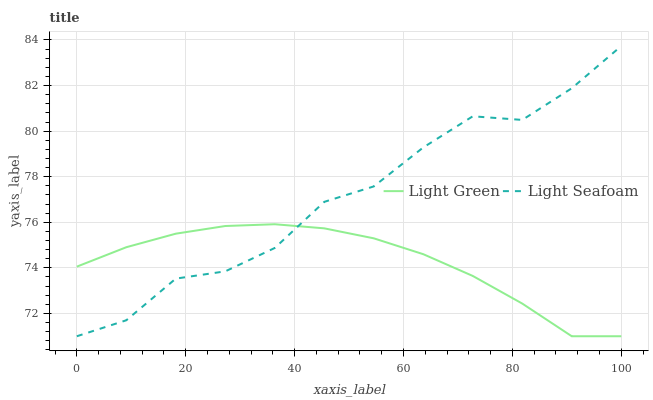Does Light Green have the maximum area under the curve?
Answer yes or no. No. Is Light Green the roughest?
Answer yes or no. No. Does Light Green have the highest value?
Answer yes or no. No. 